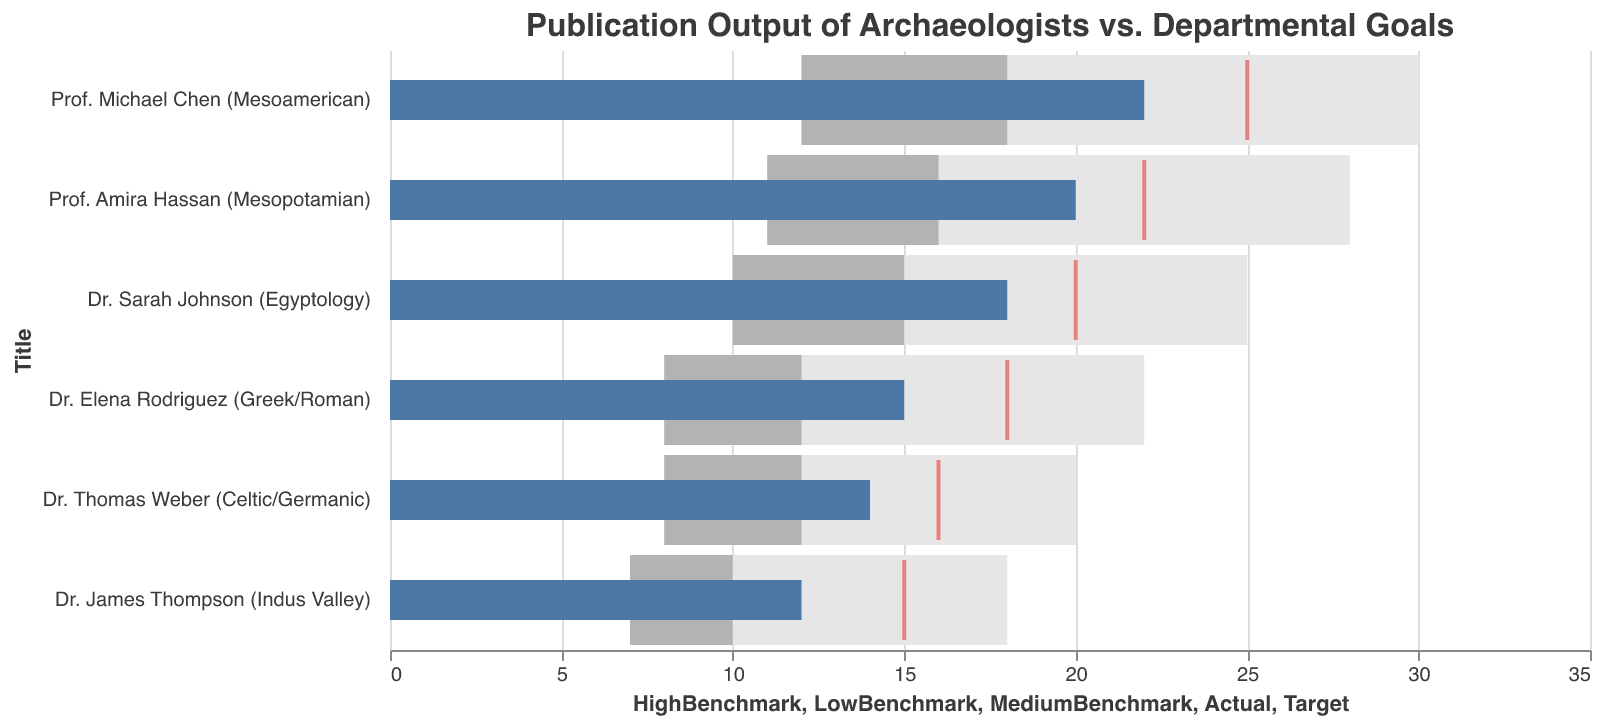what's the title of the figure? The title is prominently displayed at the top. It reads "Publication Output of Archaeologists vs. Departmental Goals".
Answer: Publication Output of Archaeologists vs. Departmental Goals how many archaeologists' publication outputs are detailed in this figure? By counting the number of distinct y-axis labels, we can determine that there are six archaeologists listed.
Answer: Six which archaeologist has the highest actual publication output? By examining the length of the blue bars representing actual publication outputs, we can see that Prof. Michael Chen has the longest bar, indicating the highest actual publication output.
Answer: Prof. Michael Chen what is the publication goal for Dr. Elena Rodriguez? The publication goals are represented by the red ticks, which are positioned along the x-axis. For Dr. Elena Rodriguez, the red tick is located at 18.
Answer: 18 did Prof. Amira Hassan meet her publication target? Compare the length of the blue bar (actual publication output) for Prof. Amira Hassan to her red tick (target). Her actual publication output (20) is less than her target (22), so she did not meet it.
Answer: No how much did Dr. James Thompson exceed the low benchmark by? Dr. James Thompson's actual publication output is 12. The LowBenchmark value for him is 7. Subtract the LowBenchmark from the actual publication to find the difference: 12 - 7 = 5.
Answer: 5 which archaeologist came closest to meeting their publication target? Compare the lengths of the blue bars (actual publication outputs) against the red ticks (targets) for all archaeologists. Dr. Sarah Johnson has an actual output of 18 and a target of 20, being the closest with a shortfall of just 2.
Answer: Dr. Sarah Johnson how many archaeologists have their actual publication output in the range between their medium and high benchmarks? We need to ascertain the actual publication number for each archaeologist and see if it falls between the MediumBenchmark and HighBenchmark. Both Dr. Sarah Johnson (18) and Prof. Amira Hassan (20) have publication outputs in these ranges. Thus, two archaeologists meet this criterion.
Answer: 2 